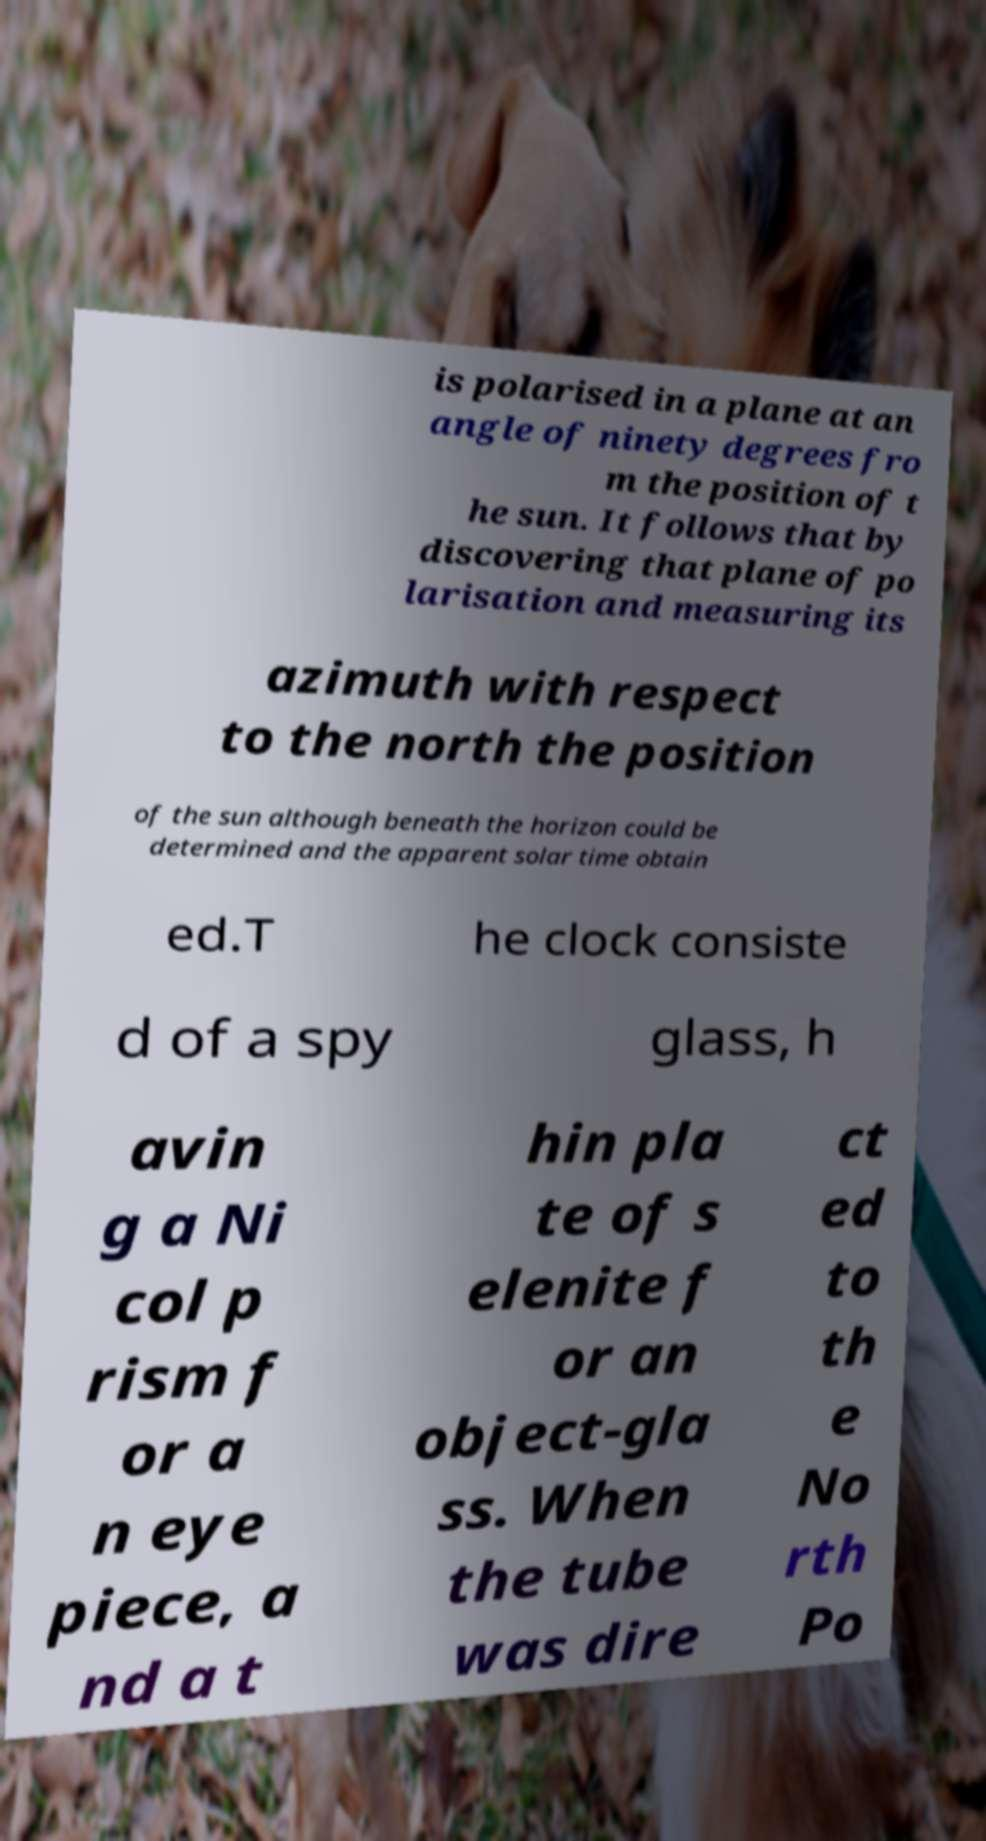Can you accurately transcribe the text from the provided image for me? is polarised in a plane at an angle of ninety degrees fro m the position of t he sun. It follows that by discovering that plane of po larisation and measuring its azimuth with respect to the north the position of the sun although beneath the horizon could be determined and the apparent solar time obtain ed.T he clock consiste d of a spy glass, h avin g a Ni col p rism f or a n eye piece, a nd a t hin pla te of s elenite f or an object-gla ss. When the tube was dire ct ed to th e No rth Po 